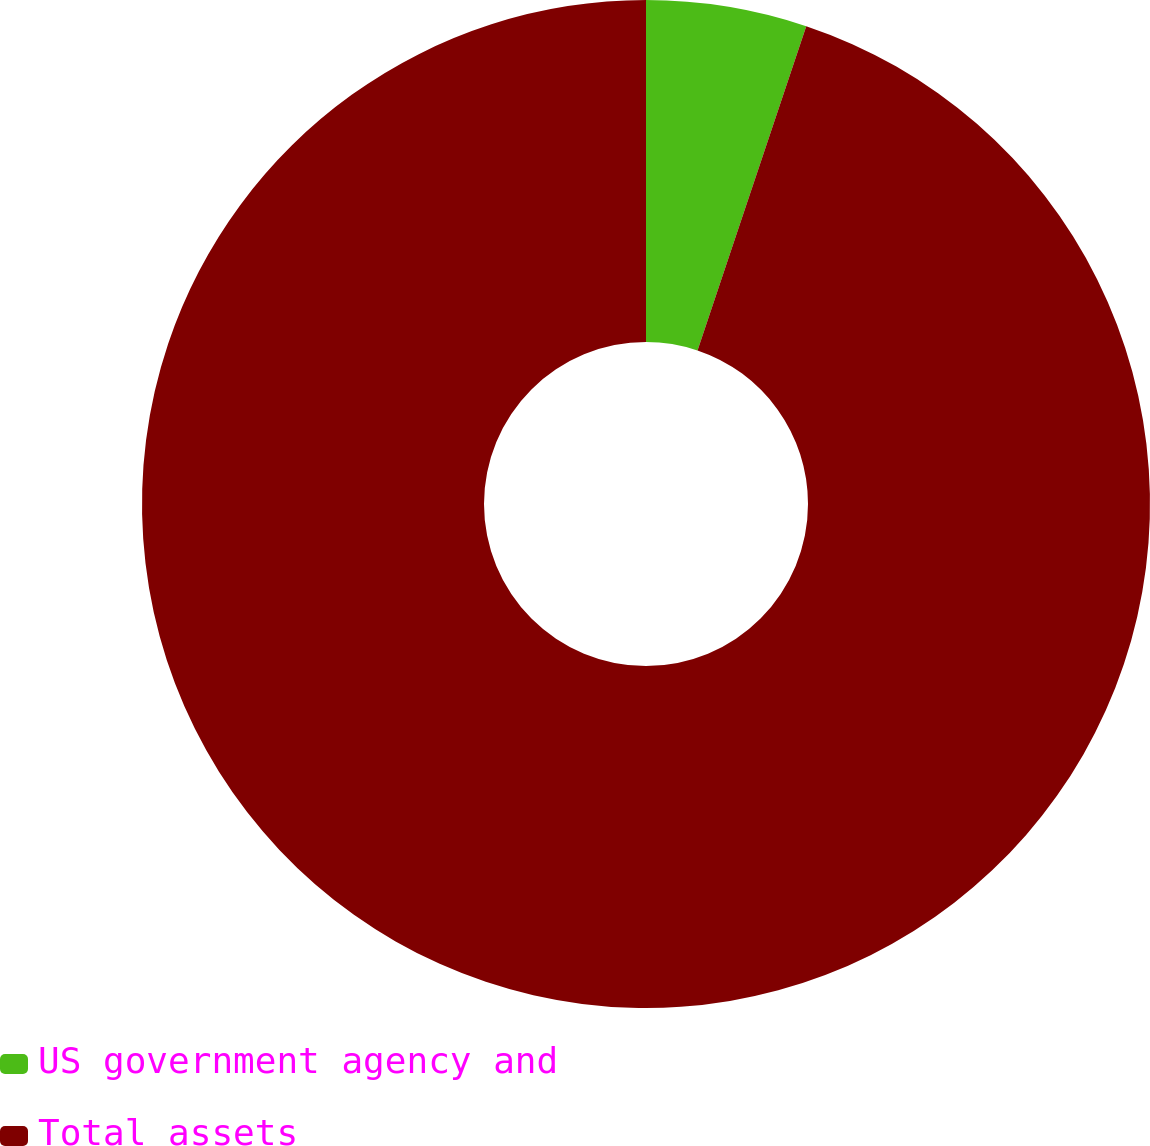<chart> <loc_0><loc_0><loc_500><loc_500><pie_chart><fcel>US government agency and<fcel>Total assets<nl><fcel>5.15%<fcel>94.85%<nl></chart> 